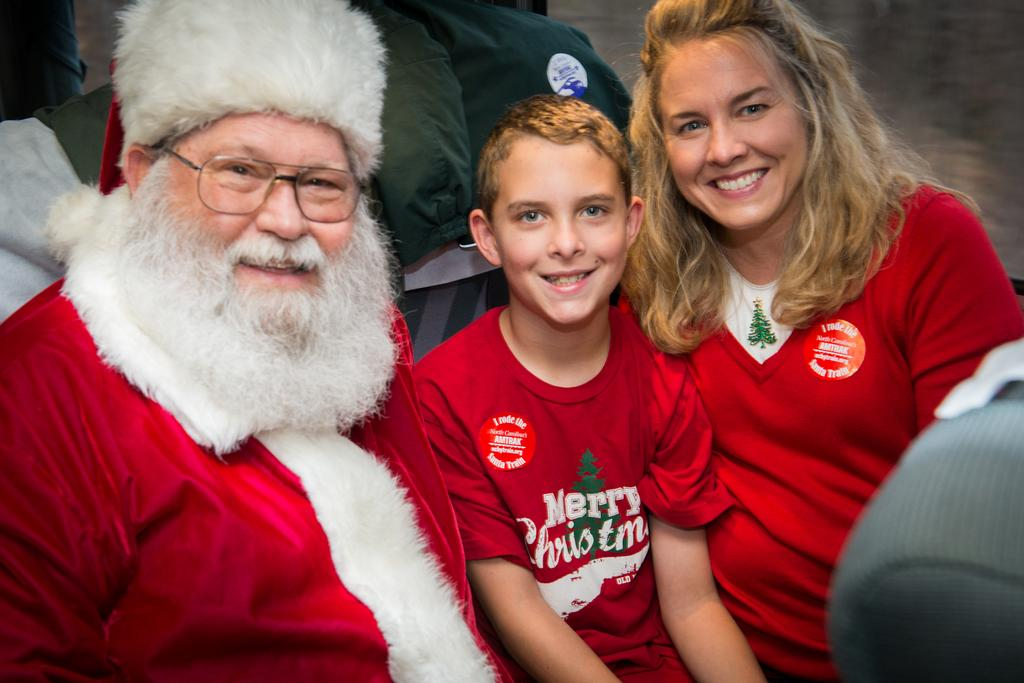Provide a one-sentence caption for the provided image. A young man sitting between Santa Claus and a woman wearing a red Merry Christmas shirt. 